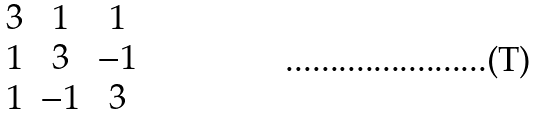Convert formula to latex. <formula><loc_0><loc_0><loc_500><loc_500>\begin{matrix} 3 & 1 & 1 \\ 1 & 3 & - 1 \\ 1 & - 1 & 3 \end{matrix}</formula> 